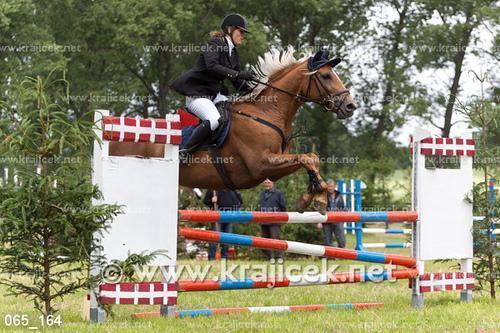How many horses are shown?
Give a very brief answer. 1. 